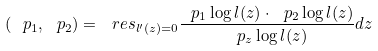Convert formula to latex. <formula><loc_0><loc_0><loc_500><loc_500>( \ p _ { 1 } , \ p _ { 2 } ) = \ r e s _ { l ^ { \prime } ( z ) = 0 } \frac { \ p _ { 1 } \log l ( z ) \cdot \ p _ { 2 } \log l ( z ) } { \ p _ { z } \log l ( z ) } d z</formula> 